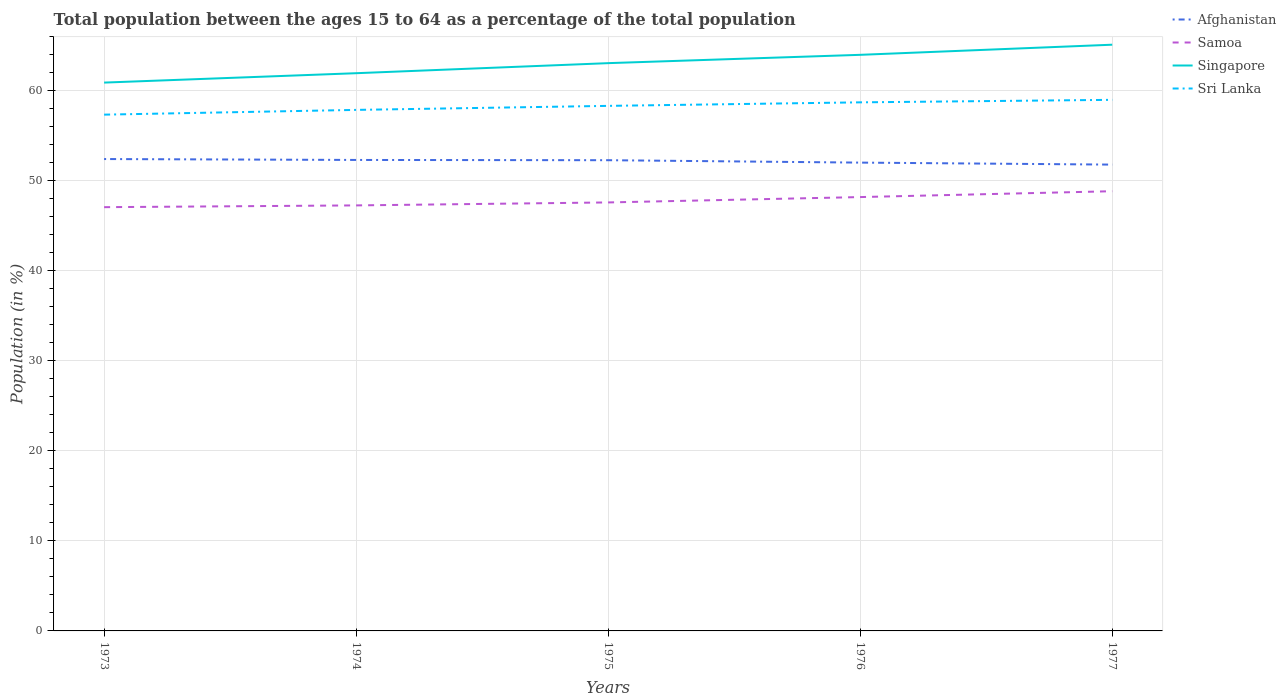Across all years, what is the maximum percentage of the population ages 15 to 64 in Samoa?
Offer a terse response. 47.06. In which year was the percentage of the population ages 15 to 64 in Sri Lanka maximum?
Provide a short and direct response. 1973. What is the total percentage of the population ages 15 to 64 in Sri Lanka in the graph?
Your answer should be compact. -0.67. What is the difference between the highest and the second highest percentage of the population ages 15 to 64 in Sri Lanka?
Your answer should be compact. 1.65. How many lines are there?
Provide a short and direct response. 4. What is the difference between two consecutive major ticks on the Y-axis?
Provide a short and direct response. 10. Are the values on the major ticks of Y-axis written in scientific E-notation?
Your answer should be very brief. No. Does the graph contain grids?
Offer a very short reply. Yes. How many legend labels are there?
Provide a short and direct response. 4. How are the legend labels stacked?
Your answer should be very brief. Vertical. What is the title of the graph?
Offer a terse response. Total population between the ages 15 to 64 as a percentage of the total population. What is the Population (in %) in Afghanistan in 1973?
Make the answer very short. 52.41. What is the Population (in %) of Samoa in 1973?
Provide a succinct answer. 47.06. What is the Population (in %) of Singapore in 1973?
Your answer should be compact. 60.9. What is the Population (in %) of Sri Lanka in 1973?
Your answer should be very brief. 57.34. What is the Population (in %) of Afghanistan in 1974?
Keep it short and to the point. 52.31. What is the Population (in %) of Samoa in 1974?
Your answer should be very brief. 47.26. What is the Population (in %) of Singapore in 1974?
Give a very brief answer. 61.94. What is the Population (in %) in Sri Lanka in 1974?
Provide a short and direct response. 57.87. What is the Population (in %) of Afghanistan in 1975?
Keep it short and to the point. 52.28. What is the Population (in %) of Samoa in 1975?
Offer a terse response. 47.59. What is the Population (in %) of Singapore in 1975?
Offer a very short reply. 63.06. What is the Population (in %) in Sri Lanka in 1975?
Give a very brief answer. 58.31. What is the Population (in %) of Afghanistan in 1976?
Your response must be concise. 52.01. What is the Population (in %) of Samoa in 1976?
Provide a short and direct response. 48.18. What is the Population (in %) of Singapore in 1976?
Keep it short and to the point. 63.98. What is the Population (in %) in Sri Lanka in 1976?
Give a very brief answer. 58.7. What is the Population (in %) of Afghanistan in 1977?
Provide a short and direct response. 51.79. What is the Population (in %) in Samoa in 1977?
Offer a very short reply. 48.83. What is the Population (in %) of Singapore in 1977?
Make the answer very short. 65.11. What is the Population (in %) of Sri Lanka in 1977?
Keep it short and to the point. 58.98. Across all years, what is the maximum Population (in %) in Afghanistan?
Your answer should be very brief. 52.41. Across all years, what is the maximum Population (in %) in Samoa?
Your answer should be compact. 48.83. Across all years, what is the maximum Population (in %) of Singapore?
Your response must be concise. 65.11. Across all years, what is the maximum Population (in %) in Sri Lanka?
Your response must be concise. 58.98. Across all years, what is the minimum Population (in %) of Afghanistan?
Offer a very short reply. 51.79. Across all years, what is the minimum Population (in %) in Samoa?
Ensure brevity in your answer.  47.06. Across all years, what is the minimum Population (in %) in Singapore?
Ensure brevity in your answer.  60.9. Across all years, what is the minimum Population (in %) in Sri Lanka?
Make the answer very short. 57.34. What is the total Population (in %) of Afghanistan in the graph?
Provide a succinct answer. 260.79. What is the total Population (in %) of Samoa in the graph?
Your response must be concise. 238.93. What is the total Population (in %) in Singapore in the graph?
Give a very brief answer. 314.98. What is the total Population (in %) of Sri Lanka in the graph?
Your answer should be very brief. 291.2. What is the difference between the Population (in %) of Afghanistan in 1973 and that in 1974?
Your answer should be very brief. 0.1. What is the difference between the Population (in %) of Samoa in 1973 and that in 1974?
Make the answer very short. -0.2. What is the difference between the Population (in %) in Singapore in 1973 and that in 1974?
Offer a very short reply. -1.04. What is the difference between the Population (in %) in Sri Lanka in 1973 and that in 1974?
Provide a succinct answer. -0.53. What is the difference between the Population (in %) in Afghanistan in 1973 and that in 1975?
Make the answer very short. 0.13. What is the difference between the Population (in %) of Samoa in 1973 and that in 1975?
Offer a very short reply. -0.53. What is the difference between the Population (in %) in Singapore in 1973 and that in 1975?
Your answer should be compact. -2.16. What is the difference between the Population (in %) of Sri Lanka in 1973 and that in 1975?
Provide a succinct answer. -0.97. What is the difference between the Population (in %) in Afghanistan in 1973 and that in 1976?
Offer a very short reply. 0.4. What is the difference between the Population (in %) in Samoa in 1973 and that in 1976?
Offer a very short reply. -1.12. What is the difference between the Population (in %) in Singapore in 1973 and that in 1976?
Ensure brevity in your answer.  -3.08. What is the difference between the Population (in %) in Sri Lanka in 1973 and that in 1976?
Offer a very short reply. -1.37. What is the difference between the Population (in %) of Afghanistan in 1973 and that in 1977?
Provide a succinct answer. 0.62. What is the difference between the Population (in %) in Samoa in 1973 and that in 1977?
Offer a terse response. -1.77. What is the difference between the Population (in %) of Singapore in 1973 and that in 1977?
Offer a terse response. -4.21. What is the difference between the Population (in %) in Sri Lanka in 1973 and that in 1977?
Your answer should be compact. -1.65. What is the difference between the Population (in %) of Afghanistan in 1974 and that in 1975?
Your answer should be very brief. 0.03. What is the difference between the Population (in %) in Samoa in 1974 and that in 1975?
Provide a succinct answer. -0.33. What is the difference between the Population (in %) of Singapore in 1974 and that in 1975?
Provide a succinct answer. -1.12. What is the difference between the Population (in %) of Sri Lanka in 1974 and that in 1975?
Give a very brief answer. -0.45. What is the difference between the Population (in %) in Afghanistan in 1974 and that in 1976?
Provide a short and direct response. 0.3. What is the difference between the Population (in %) in Samoa in 1974 and that in 1976?
Provide a succinct answer. -0.92. What is the difference between the Population (in %) in Singapore in 1974 and that in 1976?
Give a very brief answer. -2.04. What is the difference between the Population (in %) in Sri Lanka in 1974 and that in 1976?
Your answer should be very brief. -0.84. What is the difference between the Population (in %) of Afghanistan in 1974 and that in 1977?
Make the answer very short. 0.52. What is the difference between the Population (in %) of Samoa in 1974 and that in 1977?
Give a very brief answer. -1.57. What is the difference between the Population (in %) of Singapore in 1974 and that in 1977?
Your answer should be compact. -3.17. What is the difference between the Population (in %) of Sri Lanka in 1974 and that in 1977?
Keep it short and to the point. -1.12. What is the difference between the Population (in %) of Afghanistan in 1975 and that in 1976?
Make the answer very short. 0.27. What is the difference between the Population (in %) of Samoa in 1975 and that in 1976?
Ensure brevity in your answer.  -0.59. What is the difference between the Population (in %) of Singapore in 1975 and that in 1976?
Provide a short and direct response. -0.92. What is the difference between the Population (in %) in Sri Lanka in 1975 and that in 1976?
Ensure brevity in your answer.  -0.39. What is the difference between the Population (in %) of Afghanistan in 1975 and that in 1977?
Keep it short and to the point. 0.49. What is the difference between the Population (in %) in Samoa in 1975 and that in 1977?
Offer a terse response. -1.25. What is the difference between the Population (in %) in Singapore in 1975 and that in 1977?
Keep it short and to the point. -2.05. What is the difference between the Population (in %) of Sri Lanka in 1975 and that in 1977?
Give a very brief answer. -0.67. What is the difference between the Population (in %) of Afghanistan in 1976 and that in 1977?
Give a very brief answer. 0.22. What is the difference between the Population (in %) in Samoa in 1976 and that in 1977?
Your answer should be compact. -0.65. What is the difference between the Population (in %) of Singapore in 1976 and that in 1977?
Give a very brief answer. -1.13. What is the difference between the Population (in %) in Sri Lanka in 1976 and that in 1977?
Make the answer very short. -0.28. What is the difference between the Population (in %) in Afghanistan in 1973 and the Population (in %) in Samoa in 1974?
Make the answer very short. 5.15. What is the difference between the Population (in %) in Afghanistan in 1973 and the Population (in %) in Singapore in 1974?
Give a very brief answer. -9.53. What is the difference between the Population (in %) of Afghanistan in 1973 and the Population (in %) of Sri Lanka in 1974?
Provide a succinct answer. -5.46. What is the difference between the Population (in %) of Samoa in 1973 and the Population (in %) of Singapore in 1974?
Ensure brevity in your answer.  -14.88. What is the difference between the Population (in %) in Samoa in 1973 and the Population (in %) in Sri Lanka in 1974?
Ensure brevity in your answer.  -10.8. What is the difference between the Population (in %) of Singapore in 1973 and the Population (in %) of Sri Lanka in 1974?
Your answer should be very brief. 3.03. What is the difference between the Population (in %) of Afghanistan in 1973 and the Population (in %) of Samoa in 1975?
Provide a short and direct response. 4.82. What is the difference between the Population (in %) in Afghanistan in 1973 and the Population (in %) in Singapore in 1975?
Provide a succinct answer. -10.65. What is the difference between the Population (in %) of Afghanistan in 1973 and the Population (in %) of Sri Lanka in 1975?
Ensure brevity in your answer.  -5.91. What is the difference between the Population (in %) in Samoa in 1973 and the Population (in %) in Singapore in 1975?
Provide a short and direct response. -15.99. What is the difference between the Population (in %) in Samoa in 1973 and the Population (in %) in Sri Lanka in 1975?
Provide a short and direct response. -11.25. What is the difference between the Population (in %) of Singapore in 1973 and the Population (in %) of Sri Lanka in 1975?
Your answer should be very brief. 2.59. What is the difference between the Population (in %) in Afghanistan in 1973 and the Population (in %) in Samoa in 1976?
Make the answer very short. 4.22. What is the difference between the Population (in %) of Afghanistan in 1973 and the Population (in %) of Singapore in 1976?
Provide a succinct answer. -11.57. What is the difference between the Population (in %) of Afghanistan in 1973 and the Population (in %) of Sri Lanka in 1976?
Ensure brevity in your answer.  -6.3. What is the difference between the Population (in %) of Samoa in 1973 and the Population (in %) of Singapore in 1976?
Provide a succinct answer. -16.92. What is the difference between the Population (in %) of Samoa in 1973 and the Population (in %) of Sri Lanka in 1976?
Keep it short and to the point. -11.64. What is the difference between the Population (in %) of Singapore in 1973 and the Population (in %) of Sri Lanka in 1976?
Make the answer very short. 2.19. What is the difference between the Population (in %) of Afghanistan in 1973 and the Population (in %) of Samoa in 1977?
Offer a terse response. 3.57. What is the difference between the Population (in %) in Afghanistan in 1973 and the Population (in %) in Singapore in 1977?
Provide a succinct answer. -12.7. What is the difference between the Population (in %) of Afghanistan in 1973 and the Population (in %) of Sri Lanka in 1977?
Offer a very short reply. -6.58. What is the difference between the Population (in %) in Samoa in 1973 and the Population (in %) in Singapore in 1977?
Your answer should be compact. -18.04. What is the difference between the Population (in %) of Samoa in 1973 and the Population (in %) of Sri Lanka in 1977?
Ensure brevity in your answer.  -11.92. What is the difference between the Population (in %) of Singapore in 1973 and the Population (in %) of Sri Lanka in 1977?
Offer a very short reply. 1.92. What is the difference between the Population (in %) of Afghanistan in 1974 and the Population (in %) of Samoa in 1975?
Provide a short and direct response. 4.72. What is the difference between the Population (in %) in Afghanistan in 1974 and the Population (in %) in Singapore in 1975?
Offer a terse response. -10.75. What is the difference between the Population (in %) of Afghanistan in 1974 and the Population (in %) of Sri Lanka in 1975?
Offer a terse response. -6.01. What is the difference between the Population (in %) of Samoa in 1974 and the Population (in %) of Singapore in 1975?
Ensure brevity in your answer.  -15.8. What is the difference between the Population (in %) of Samoa in 1974 and the Population (in %) of Sri Lanka in 1975?
Give a very brief answer. -11.05. What is the difference between the Population (in %) of Singapore in 1974 and the Population (in %) of Sri Lanka in 1975?
Give a very brief answer. 3.63. What is the difference between the Population (in %) in Afghanistan in 1974 and the Population (in %) in Samoa in 1976?
Make the answer very short. 4.12. What is the difference between the Population (in %) of Afghanistan in 1974 and the Population (in %) of Singapore in 1976?
Give a very brief answer. -11.67. What is the difference between the Population (in %) of Afghanistan in 1974 and the Population (in %) of Sri Lanka in 1976?
Offer a terse response. -6.4. What is the difference between the Population (in %) in Samoa in 1974 and the Population (in %) in Singapore in 1976?
Your answer should be very brief. -16.72. What is the difference between the Population (in %) in Samoa in 1974 and the Population (in %) in Sri Lanka in 1976?
Keep it short and to the point. -11.45. What is the difference between the Population (in %) of Singapore in 1974 and the Population (in %) of Sri Lanka in 1976?
Make the answer very short. 3.24. What is the difference between the Population (in %) of Afghanistan in 1974 and the Population (in %) of Samoa in 1977?
Your answer should be compact. 3.47. What is the difference between the Population (in %) of Afghanistan in 1974 and the Population (in %) of Singapore in 1977?
Your answer should be very brief. -12.8. What is the difference between the Population (in %) of Afghanistan in 1974 and the Population (in %) of Sri Lanka in 1977?
Make the answer very short. -6.68. What is the difference between the Population (in %) of Samoa in 1974 and the Population (in %) of Singapore in 1977?
Your response must be concise. -17.85. What is the difference between the Population (in %) in Samoa in 1974 and the Population (in %) in Sri Lanka in 1977?
Your answer should be very brief. -11.72. What is the difference between the Population (in %) of Singapore in 1974 and the Population (in %) of Sri Lanka in 1977?
Ensure brevity in your answer.  2.96. What is the difference between the Population (in %) of Afghanistan in 1975 and the Population (in %) of Samoa in 1976?
Keep it short and to the point. 4.1. What is the difference between the Population (in %) in Afghanistan in 1975 and the Population (in %) in Singapore in 1976?
Make the answer very short. -11.7. What is the difference between the Population (in %) in Afghanistan in 1975 and the Population (in %) in Sri Lanka in 1976?
Ensure brevity in your answer.  -6.43. What is the difference between the Population (in %) in Samoa in 1975 and the Population (in %) in Singapore in 1976?
Your answer should be compact. -16.39. What is the difference between the Population (in %) of Samoa in 1975 and the Population (in %) of Sri Lanka in 1976?
Make the answer very short. -11.12. What is the difference between the Population (in %) of Singapore in 1975 and the Population (in %) of Sri Lanka in 1976?
Your answer should be compact. 4.35. What is the difference between the Population (in %) in Afghanistan in 1975 and the Population (in %) in Samoa in 1977?
Offer a terse response. 3.44. What is the difference between the Population (in %) of Afghanistan in 1975 and the Population (in %) of Singapore in 1977?
Your answer should be compact. -12.83. What is the difference between the Population (in %) of Afghanistan in 1975 and the Population (in %) of Sri Lanka in 1977?
Offer a terse response. -6.7. What is the difference between the Population (in %) of Samoa in 1975 and the Population (in %) of Singapore in 1977?
Offer a very short reply. -17.52. What is the difference between the Population (in %) in Samoa in 1975 and the Population (in %) in Sri Lanka in 1977?
Make the answer very short. -11.39. What is the difference between the Population (in %) in Singapore in 1975 and the Population (in %) in Sri Lanka in 1977?
Your answer should be very brief. 4.07. What is the difference between the Population (in %) of Afghanistan in 1976 and the Population (in %) of Samoa in 1977?
Keep it short and to the point. 3.18. What is the difference between the Population (in %) of Afghanistan in 1976 and the Population (in %) of Singapore in 1977?
Give a very brief answer. -13.1. What is the difference between the Population (in %) of Afghanistan in 1976 and the Population (in %) of Sri Lanka in 1977?
Provide a short and direct response. -6.97. What is the difference between the Population (in %) of Samoa in 1976 and the Population (in %) of Singapore in 1977?
Give a very brief answer. -16.92. What is the difference between the Population (in %) of Samoa in 1976 and the Population (in %) of Sri Lanka in 1977?
Keep it short and to the point. -10.8. What is the difference between the Population (in %) in Singapore in 1976 and the Population (in %) in Sri Lanka in 1977?
Provide a short and direct response. 5. What is the average Population (in %) of Afghanistan per year?
Your response must be concise. 52.16. What is the average Population (in %) in Samoa per year?
Your response must be concise. 47.78. What is the average Population (in %) of Singapore per year?
Keep it short and to the point. 63. What is the average Population (in %) of Sri Lanka per year?
Offer a very short reply. 58.24. In the year 1973, what is the difference between the Population (in %) in Afghanistan and Population (in %) in Samoa?
Provide a succinct answer. 5.34. In the year 1973, what is the difference between the Population (in %) in Afghanistan and Population (in %) in Singapore?
Offer a terse response. -8.49. In the year 1973, what is the difference between the Population (in %) of Afghanistan and Population (in %) of Sri Lanka?
Your answer should be very brief. -4.93. In the year 1973, what is the difference between the Population (in %) of Samoa and Population (in %) of Singapore?
Your response must be concise. -13.84. In the year 1973, what is the difference between the Population (in %) in Samoa and Population (in %) in Sri Lanka?
Your answer should be compact. -10.28. In the year 1973, what is the difference between the Population (in %) in Singapore and Population (in %) in Sri Lanka?
Give a very brief answer. 3.56. In the year 1974, what is the difference between the Population (in %) of Afghanistan and Population (in %) of Samoa?
Your answer should be very brief. 5.05. In the year 1974, what is the difference between the Population (in %) in Afghanistan and Population (in %) in Singapore?
Provide a succinct answer. -9.63. In the year 1974, what is the difference between the Population (in %) in Afghanistan and Population (in %) in Sri Lanka?
Make the answer very short. -5.56. In the year 1974, what is the difference between the Population (in %) of Samoa and Population (in %) of Singapore?
Make the answer very short. -14.68. In the year 1974, what is the difference between the Population (in %) in Samoa and Population (in %) in Sri Lanka?
Make the answer very short. -10.61. In the year 1974, what is the difference between the Population (in %) in Singapore and Population (in %) in Sri Lanka?
Ensure brevity in your answer.  4.08. In the year 1975, what is the difference between the Population (in %) in Afghanistan and Population (in %) in Samoa?
Make the answer very short. 4.69. In the year 1975, what is the difference between the Population (in %) in Afghanistan and Population (in %) in Singapore?
Offer a terse response. -10.78. In the year 1975, what is the difference between the Population (in %) in Afghanistan and Population (in %) in Sri Lanka?
Make the answer very short. -6.03. In the year 1975, what is the difference between the Population (in %) in Samoa and Population (in %) in Singapore?
Provide a succinct answer. -15.47. In the year 1975, what is the difference between the Population (in %) of Samoa and Population (in %) of Sri Lanka?
Your response must be concise. -10.72. In the year 1975, what is the difference between the Population (in %) in Singapore and Population (in %) in Sri Lanka?
Give a very brief answer. 4.74. In the year 1976, what is the difference between the Population (in %) in Afghanistan and Population (in %) in Samoa?
Offer a very short reply. 3.83. In the year 1976, what is the difference between the Population (in %) of Afghanistan and Population (in %) of Singapore?
Provide a short and direct response. -11.97. In the year 1976, what is the difference between the Population (in %) in Afghanistan and Population (in %) in Sri Lanka?
Offer a terse response. -6.69. In the year 1976, what is the difference between the Population (in %) of Samoa and Population (in %) of Singapore?
Provide a succinct answer. -15.8. In the year 1976, what is the difference between the Population (in %) of Samoa and Population (in %) of Sri Lanka?
Provide a succinct answer. -10.52. In the year 1976, what is the difference between the Population (in %) in Singapore and Population (in %) in Sri Lanka?
Provide a succinct answer. 5.28. In the year 1977, what is the difference between the Population (in %) in Afghanistan and Population (in %) in Samoa?
Give a very brief answer. 2.96. In the year 1977, what is the difference between the Population (in %) of Afghanistan and Population (in %) of Singapore?
Your answer should be very brief. -13.32. In the year 1977, what is the difference between the Population (in %) of Afghanistan and Population (in %) of Sri Lanka?
Give a very brief answer. -7.19. In the year 1977, what is the difference between the Population (in %) in Samoa and Population (in %) in Singapore?
Make the answer very short. -16.27. In the year 1977, what is the difference between the Population (in %) of Samoa and Population (in %) of Sri Lanka?
Keep it short and to the point. -10.15. In the year 1977, what is the difference between the Population (in %) of Singapore and Population (in %) of Sri Lanka?
Provide a short and direct response. 6.12. What is the ratio of the Population (in %) in Afghanistan in 1973 to that in 1974?
Give a very brief answer. 1. What is the ratio of the Population (in %) of Samoa in 1973 to that in 1974?
Make the answer very short. 1. What is the ratio of the Population (in %) of Singapore in 1973 to that in 1974?
Your response must be concise. 0.98. What is the ratio of the Population (in %) of Sri Lanka in 1973 to that in 1974?
Your answer should be compact. 0.99. What is the ratio of the Population (in %) in Afghanistan in 1973 to that in 1975?
Keep it short and to the point. 1. What is the ratio of the Population (in %) of Samoa in 1973 to that in 1975?
Give a very brief answer. 0.99. What is the ratio of the Population (in %) in Singapore in 1973 to that in 1975?
Make the answer very short. 0.97. What is the ratio of the Population (in %) of Sri Lanka in 1973 to that in 1975?
Your answer should be very brief. 0.98. What is the ratio of the Population (in %) in Afghanistan in 1973 to that in 1976?
Give a very brief answer. 1.01. What is the ratio of the Population (in %) in Samoa in 1973 to that in 1976?
Keep it short and to the point. 0.98. What is the ratio of the Population (in %) of Singapore in 1973 to that in 1976?
Your answer should be very brief. 0.95. What is the ratio of the Population (in %) of Sri Lanka in 1973 to that in 1976?
Provide a succinct answer. 0.98. What is the ratio of the Population (in %) in Afghanistan in 1973 to that in 1977?
Provide a succinct answer. 1.01. What is the ratio of the Population (in %) in Samoa in 1973 to that in 1977?
Your answer should be very brief. 0.96. What is the ratio of the Population (in %) in Singapore in 1973 to that in 1977?
Offer a terse response. 0.94. What is the ratio of the Population (in %) of Sri Lanka in 1973 to that in 1977?
Make the answer very short. 0.97. What is the ratio of the Population (in %) in Samoa in 1974 to that in 1975?
Offer a terse response. 0.99. What is the ratio of the Population (in %) of Singapore in 1974 to that in 1975?
Provide a succinct answer. 0.98. What is the ratio of the Population (in %) in Afghanistan in 1974 to that in 1976?
Your response must be concise. 1.01. What is the ratio of the Population (in %) of Samoa in 1974 to that in 1976?
Make the answer very short. 0.98. What is the ratio of the Population (in %) in Singapore in 1974 to that in 1976?
Your response must be concise. 0.97. What is the ratio of the Population (in %) in Sri Lanka in 1974 to that in 1976?
Provide a succinct answer. 0.99. What is the ratio of the Population (in %) in Samoa in 1974 to that in 1977?
Offer a very short reply. 0.97. What is the ratio of the Population (in %) of Singapore in 1974 to that in 1977?
Offer a terse response. 0.95. What is the ratio of the Population (in %) in Sri Lanka in 1974 to that in 1977?
Keep it short and to the point. 0.98. What is the ratio of the Population (in %) in Afghanistan in 1975 to that in 1976?
Ensure brevity in your answer.  1.01. What is the ratio of the Population (in %) in Samoa in 1975 to that in 1976?
Your answer should be compact. 0.99. What is the ratio of the Population (in %) in Singapore in 1975 to that in 1976?
Offer a terse response. 0.99. What is the ratio of the Population (in %) in Sri Lanka in 1975 to that in 1976?
Your answer should be very brief. 0.99. What is the ratio of the Population (in %) of Afghanistan in 1975 to that in 1977?
Offer a terse response. 1.01. What is the ratio of the Population (in %) in Samoa in 1975 to that in 1977?
Give a very brief answer. 0.97. What is the ratio of the Population (in %) of Singapore in 1975 to that in 1977?
Ensure brevity in your answer.  0.97. What is the ratio of the Population (in %) in Sri Lanka in 1975 to that in 1977?
Your response must be concise. 0.99. What is the ratio of the Population (in %) in Afghanistan in 1976 to that in 1977?
Provide a short and direct response. 1. What is the ratio of the Population (in %) of Samoa in 1976 to that in 1977?
Offer a terse response. 0.99. What is the ratio of the Population (in %) in Singapore in 1976 to that in 1977?
Your answer should be compact. 0.98. What is the ratio of the Population (in %) of Sri Lanka in 1976 to that in 1977?
Make the answer very short. 1. What is the difference between the highest and the second highest Population (in %) in Afghanistan?
Offer a terse response. 0.1. What is the difference between the highest and the second highest Population (in %) of Samoa?
Make the answer very short. 0.65. What is the difference between the highest and the second highest Population (in %) in Singapore?
Provide a short and direct response. 1.13. What is the difference between the highest and the second highest Population (in %) in Sri Lanka?
Make the answer very short. 0.28. What is the difference between the highest and the lowest Population (in %) of Afghanistan?
Ensure brevity in your answer.  0.62. What is the difference between the highest and the lowest Population (in %) of Samoa?
Your response must be concise. 1.77. What is the difference between the highest and the lowest Population (in %) of Singapore?
Offer a terse response. 4.21. What is the difference between the highest and the lowest Population (in %) in Sri Lanka?
Offer a terse response. 1.65. 